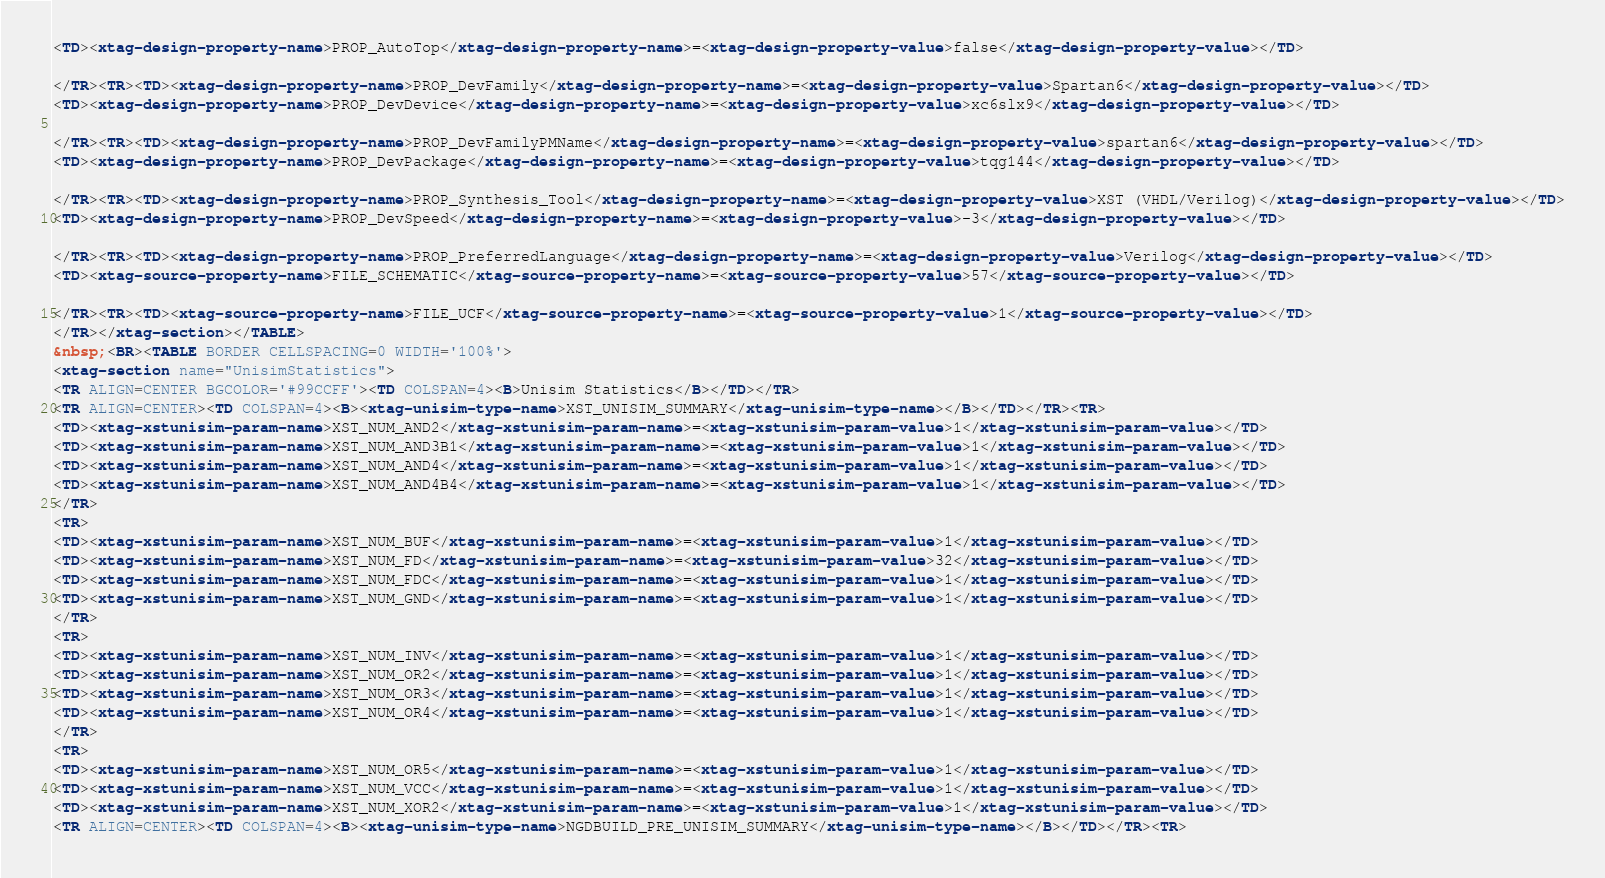<code> <loc_0><loc_0><loc_500><loc_500><_HTML_><TD><xtag-design-property-name>PROP_AutoTop</xtag-design-property-name>=<xtag-design-property-value>false</xtag-design-property-value></TD>

</TR><TR><TD><xtag-design-property-name>PROP_DevFamily</xtag-design-property-name>=<xtag-design-property-value>Spartan6</xtag-design-property-value></TD>
<TD><xtag-design-property-name>PROP_DevDevice</xtag-design-property-name>=<xtag-design-property-value>xc6slx9</xtag-design-property-value></TD>

</TR><TR><TD><xtag-design-property-name>PROP_DevFamilyPMName</xtag-design-property-name>=<xtag-design-property-value>spartan6</xtag-design-property-value></TD>
<TD><xtag-design-property-name>PROP_DevPackage</xtag-design-property-name>=<xtag-design-property-value>tqg144</xtag-design-property-value></TD>

</TR><TR><TD><xtag-design-property-name>PROP_Synthesis_Tool</xtag-design-property-name>=<xtag-design-property-value>XST (VHDL/Verilog)</xtag-design-property-value></TD>
<TD><xtag-design-property-name>PROP_DevSpeed</xtag-design-property-name>=<xtag-design-property-value>-3</xtag-design-property-value></TD>

</TR><TR><TD><xtag-design-property-name>PROP_PreferredLanguage</xtag-design-property-name>=<xtag-design-property-value>Verilog</xtag-design-property-value></TD>
<TD><xtag-source-property-name>FILE_SCHEMATIC</xtag-source-property-name>=<xtag-source-property-value>57</xtag-source-property-value></TD>

</TR><TR><TD><xtag-source-property-name>FILE_UCF</xtag-source-property-name>=<xtag-source-property-value>1</xtag-source-property-value></TD>
</TR></xtag-section></TABLE>
&nbsp;<BR><TABLE BORDER CELLSPACING=0 WIDTH='100%'>
<xtag-section name="UnisimStatistics">
<TR ALIGN=CENTER BGCOLOR='#99CCFF'><TD COLSPAN=4><B>Unisim Statistics</B></TD></TR>
<TR ALIGN=CENTER><TD COLSPAN=4><B><xtag-unisim-type-name>XST_UNISIM_SUMMARY</xtag-unisim-type-name></B></TD></TR><TR>
<TD><xtag-xstunisim-param-name>XST_NUM_AND2</xtag-xstunisim-param-name>=<xtag-xstunisim-param-value>1</xtag-xstunisim-param-value></TD>
<TD><xtag-xstunisim-param-name>XST_NUM_AND3B1</xtag-xstunisim-param-name>=<xtag-xstunisim-param-value>1</xtag-xstunisim-param-value></TD>
<TD><xtag-xstunisim-param-name>XST_NUM_AND4</xtag-xstunisim-param-name>=<xtag-xstunisim-param-value>1</xtag-xstunisim-param-value></TD>
<TD><xtag-xstunisim-param-name>XST_NUM_AND4B4</xtag-xstunisim-param-name>=<xtag-xstunisim-param-value>1</xtag-xstunisim-param-value></TD>
</TR>
<TR>
<TD><xtag-xstunisim-param-name>XST_NUM_BUF</xtag-xstunisim-param-name>=<xtag-xstunisim-param-value>1</xtag-xstunisim-param-value></TD>
<TD><xtag-xstunisim-param-name>XST_NUM_FD</xtag-xstunisim-param-name>=<xtag-xstunisim-param-value>32</xtag-xstunisim-param-value></TD>
<TD><xtag-xstunisim-param-name>XST_NUM_FDC</xtag-xstunisim-param-name>=<xtag-xstunisim-param-value>1</xtag-xstunisim-param-value></TD>
<TD><xtag-xstunisim-param-name>XST_NUM_GND</xtag-xstunisim-param-name>=<xtag-xstunisim-param-value>1</xtag-xstunisim-param-value></TD>
</TR>
<TR>
<TD><xtag-xstunisim-param-name>XST_NUM_INV</xtag-xstunisim-param-name>=<xtag-xstunisim-param-value>1</xtag-xstunisim-param-value></TD>
<TD><xtag-xstunisim-param-name>XST_NUM_OR2</xtag-xstunisim-param-name>=<xtag-xstunisim-param-value>1</xtag-xstunisim-param-value></TD>
<TD><xtag-xstunisim-param-name>XST_NUM_OR3</xtag-xstunisim-param-name>=<xtag-xstunisim-param-value>1</xtag-xstunisim-param-value></TD>
<TD><xtag-xstunisim-param-name>XST_NUM_OR4</xtag-xstunisim-param-name>=<xtag-xstunisim-param-value>1</xtag-xstunisim-param-value></TD>
</TR>
<TR>
<TD><xtag-xstunisim-param-name>XST_NUM_OR5</xtag-xstunisim-param-name>=<xtag-xstunisim-param-value>1</xtag-xstunisim-param-value></TD>
<TD><xtag-xstunisim-param-name>XST_NUM_VCC</xtag-xstunisim-param-name>=<xtag-xstunisim-param-value>1</xtag-xstunisim-param-value></TD>
<TD><xtag-xstunisim-param-name>XST_NUM_XOR2</xtag-xstunisim-param-name>=<xtag-xstunisim-param-value>1</xtag-xstunisim-param-value></TD>
<TR ALIGN=CENTER><TD COLSPAN=4><B><xtag-unisim-type-name>NGDBUILD_PRE_UNISIM_SUMMARY</xtag-unisim-type-name></B></TD></TR><TR></code> 